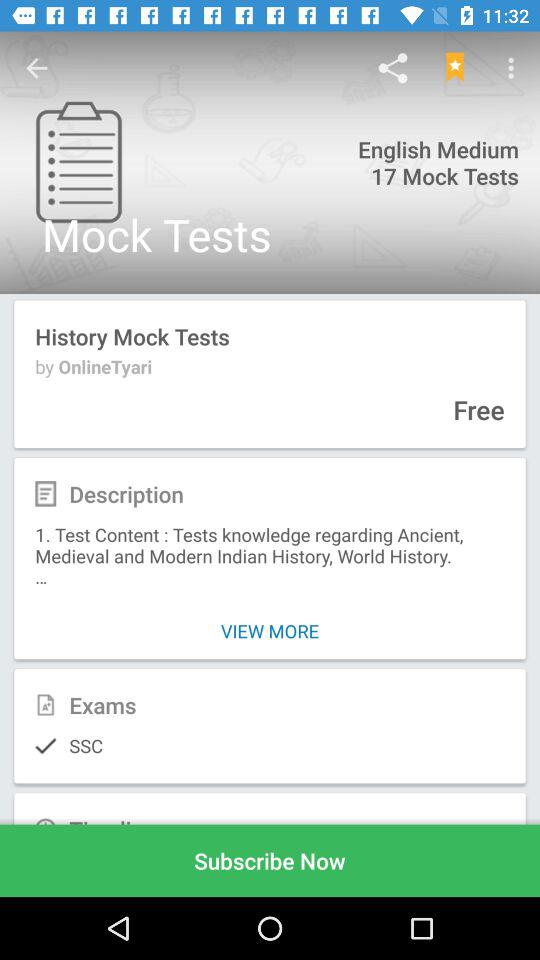Which language is selected? The selected language is English. 